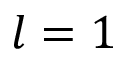Convert formula to latex. <formula><loc_0><loc_0><loc_500><loc_500>l = 1</formula> 